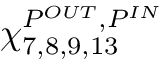Convert formula to latex. <formula><loc_0><loc_0><loc_500><loc_500>\chi _ { 7 , 8 , 9 , 1 3 } ^ { P ^ { O U T } , P ^ { I N } }</formula> 